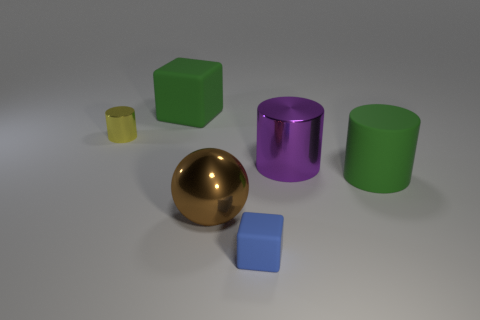Is the shape of the small object to the left of the blue cube the same as the green object behind the matte cylinder?
Make the answer very short. No. There is a big matte object on the left side of the big shiny ball; are there any green matte cubes that are on the right side of it?
Ensure brevity in your answer.  No. Are any metal things visible?
Your answer should be compact. Yes. How many purple cubes have the same size as the blue matte cube?
Provide a succinct answer. 0. What number of objects are both in front of the small metal thing and left of the tiny blue block?
Offer a terse response. 1. There is a metallic object in front of the green cylinder; is its size the same as the large green rubber block?
Your answer should be very brief. Yes. Are there any metallic spheres that have the same color as the large shiny cylinder?
Provide a succinct answer. No. The purple object that is the same material as the yellow object is what size?
Your response must be concise. Large. Are there more big purple cylinders that are on the left side of the tiny metallic object than metal spheres in front of the small matte cube?
Offer a terse response. No. How many other things are there of the same material as the ball?
Offer a very short reply. 2. 